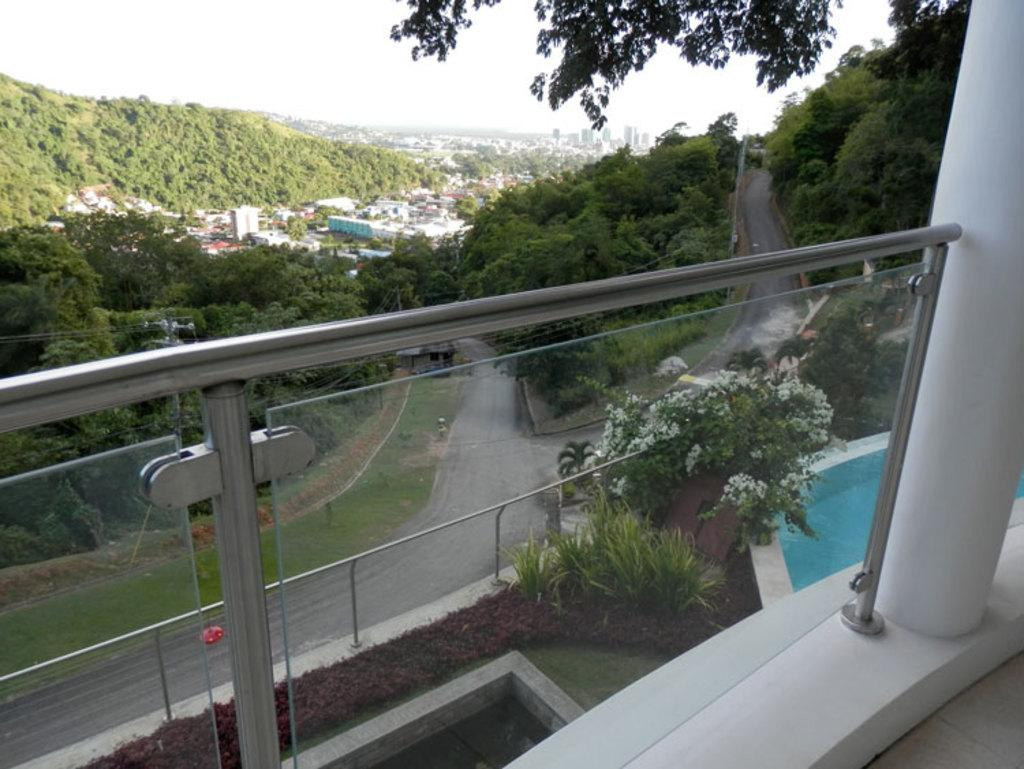What structure can be seen in the image that is elevated from the ground? There is a balcony in the image. What is located in front of the balcony? There is a plant with flowers in front of the balcony. What type of outdoor feature can be seen in the image? There is a road visible in the image. What type of vegetation is present in the image? There are trees in the image. What type of man-made structures are visible in the image? There are buildings in the image. How much does the plane cost in the image? There is no plane present in the image, so it is not possible to determine its cost. How many clocks can be seen in the image? There are no clocks visible in the image. 